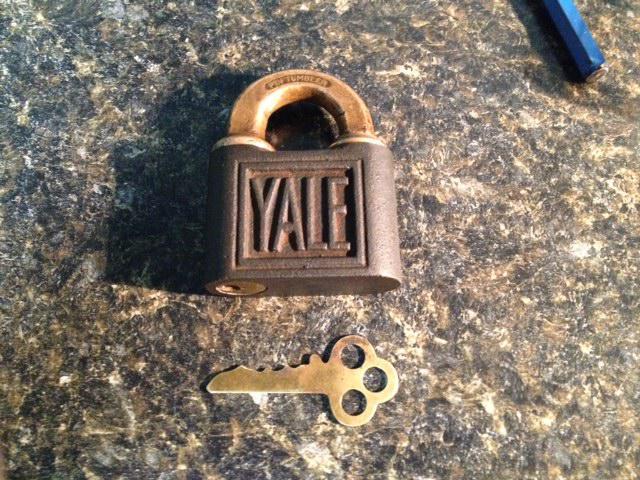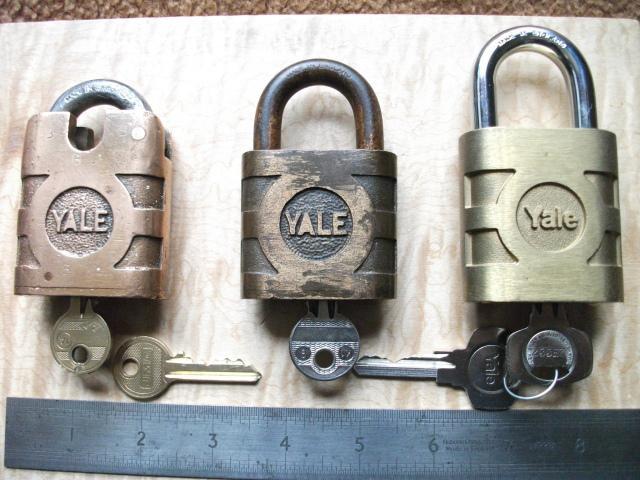The first image is the image on the left, the second image is the image on the right. Analyze the images presented: Is the assertion "There are four closed and locked padlocks in total." valid? Answer yes or no. Yes. The first image is the image on the left, the second image is the image on the right. Analyze the images presented: Is the assertion "An image shows three locks of similar style and includes some keys." valid? Answer yes or no. Yes. 